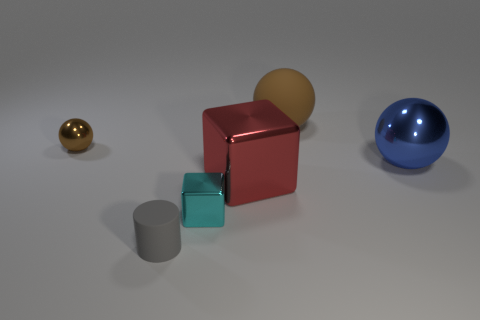There is a cyan metal object; is it the same shape as the thing in front of the small cyan shiny thing?
Make the answer very short. No. How many matte objects are either red cubes or blue things?
Give a very brief answer. 0. Are there any shiny cubes that have the same color as the tiny shiny sphere?
Ensure brevity in your answer.  No. Are there any tiny cyan metallic cubes?
Offer a very short reply. Yes. Do the big red shiny thing and the large brown object have the same shape?
Your answer should be very brief. No. How many tiny things are red metal objects or rubber objects?
Give a very brief answer. 1. What is the color of the large metallic block?
Ensure brevity in your answer.  Red. What shape is the rubber thing that is in front of the brown sphere that is left of the cyan thing?
Your response must be concise. Cylinder. Is there a large brown block made of the same material as the large blue object?
Your answer should be compact. No. Is the size of the thing to the left of the gray object the same as the large blue sphere?
Your answer should be very brief. No. 